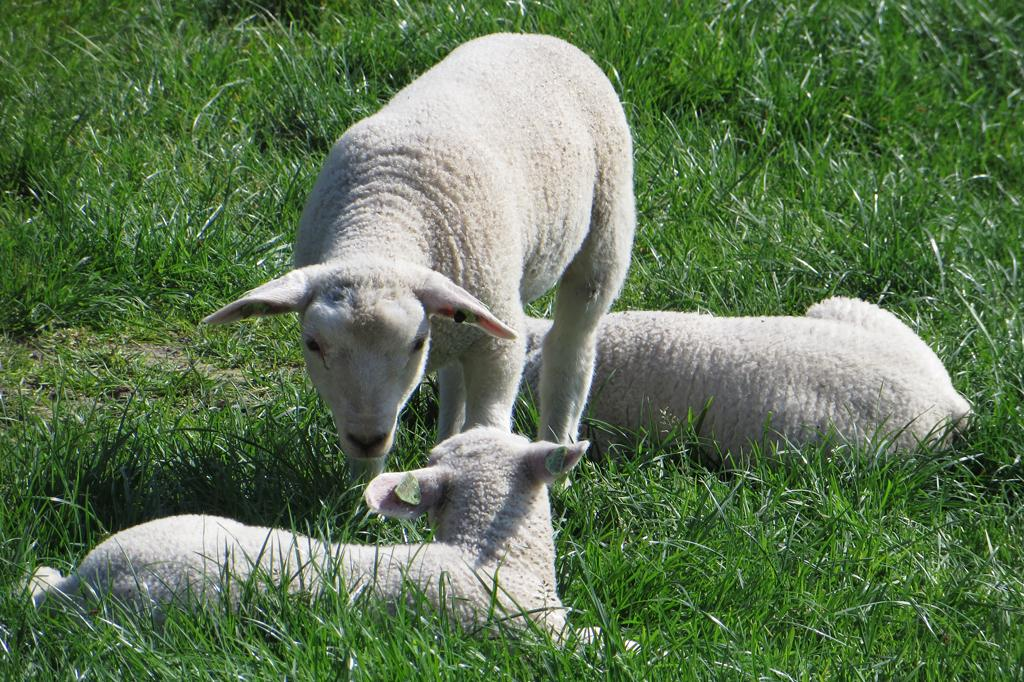What is the main subject of the image? There is a white color sheep in the image. Where is the white sheep located in the image? The sheep is standing in the middle of the ground. Are there any other sheep in the image? Yes, there are two more sheep in the image. What are the two additional sheep doing in the image? The two additional sheep are sitting on the grass ground. How many ladybugs can be seen on the sheep in the image? There are no ladybugs visible on the sheep in the image. What type of mint is growing on the grass ground in the image? There is no mint visible on the grass ground in the image. 